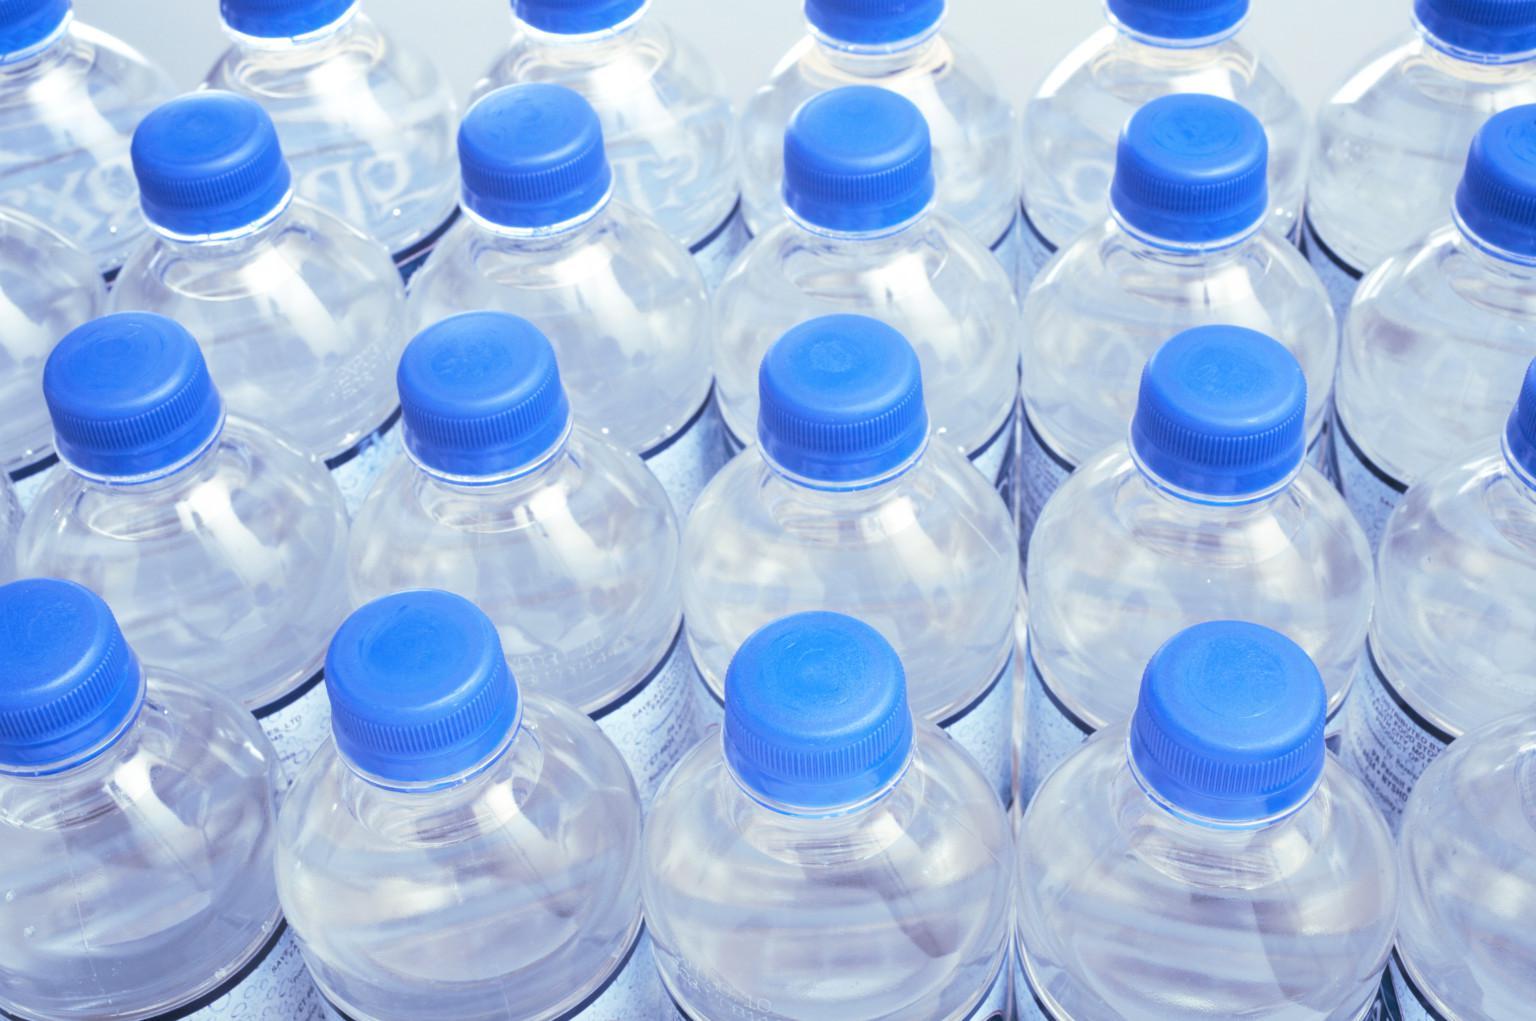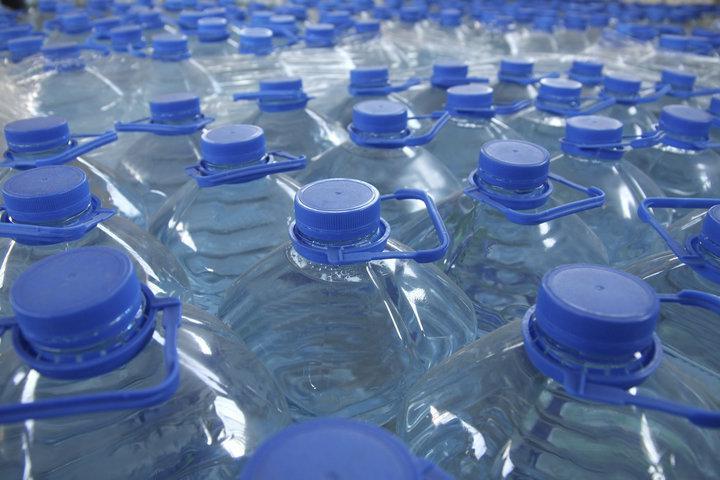The first image is the image on the left, the second image is the image on the right. Considering the images on both sides, is "an image shows individual, unwrapped bottles with white lids." valid? Answer yes or no. No. The first image is the image on the left, the second image is the image on the right. Examine the images to the left and right. Is the description "Bottles with blue caps are on a blue grated surface." accurate? Answer yes or no. No. 